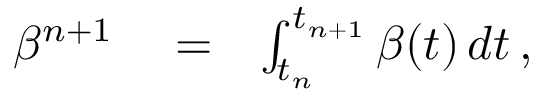<formula> <loc_0><loc_0><loc_500><loc_500>\begin{array} { r l r } { \beta ^ { n + 1 } } & = } & { \int _ { t _ { n } } ^ { t _ { n + 1 } } \beta ( t ) \, d t \, , } \end{array}</formula> 